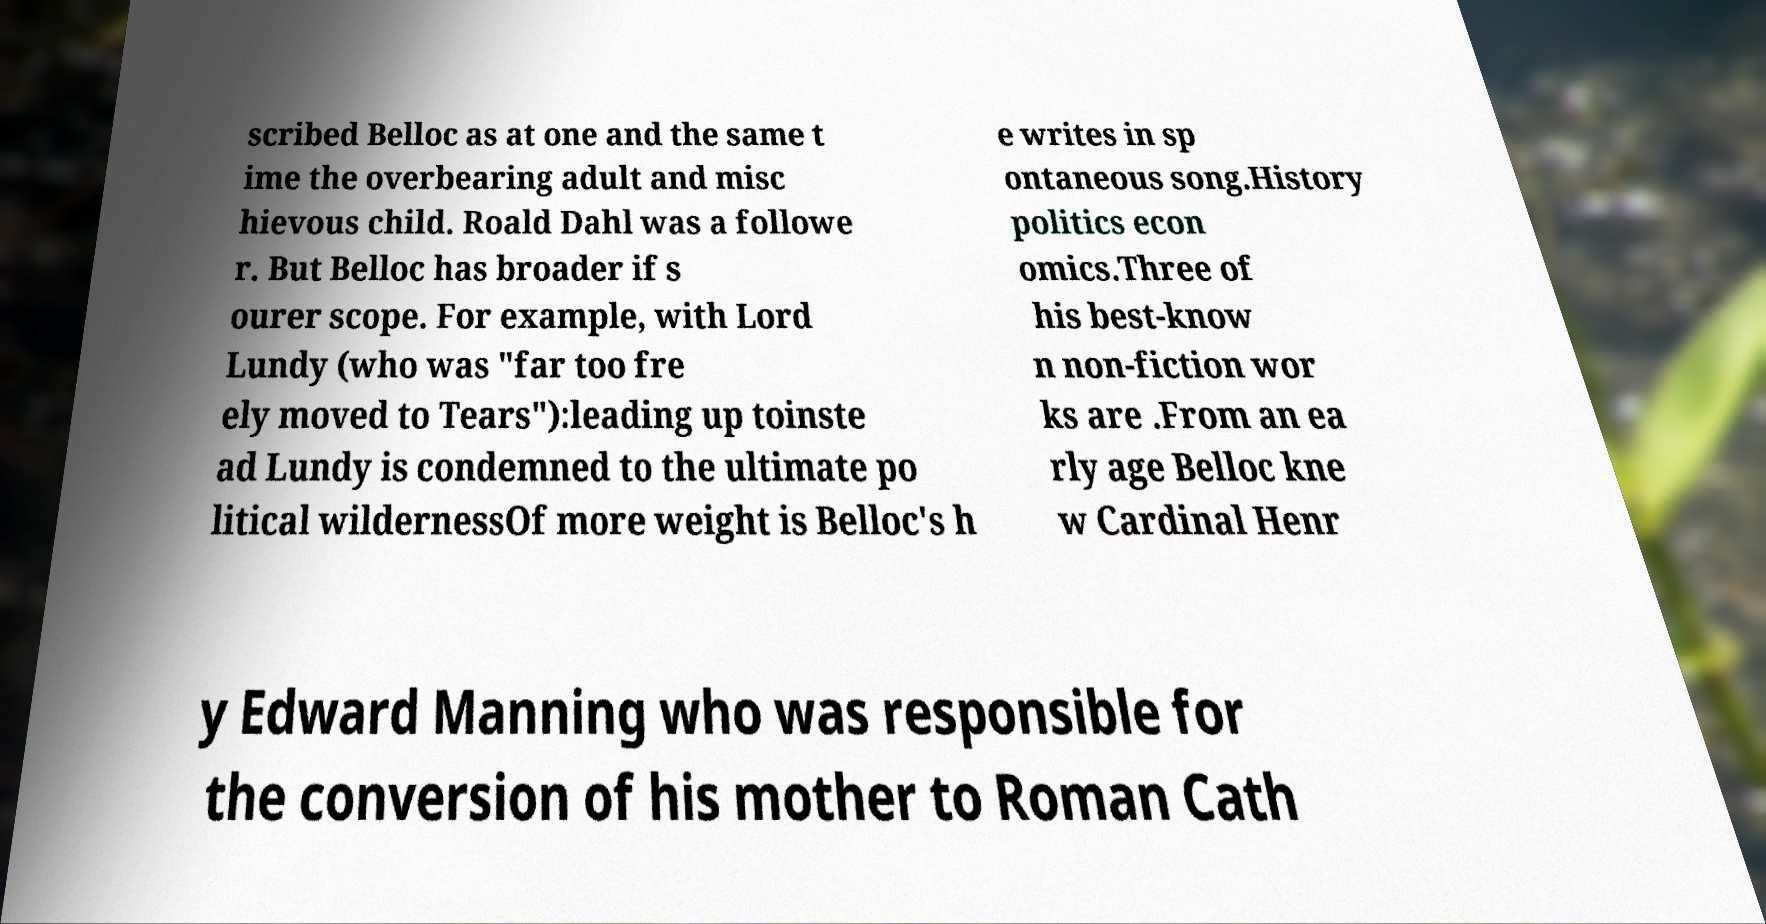I need the written content from this picture converted into text. Can you do that? scribed Belloc as at one and the same t ime the overbearing adult and misc hievous child. Roald Dahl was a followe r. But Belloc has broader if s ourer scope. For example, with Lord Lundy (who was "far too fre ely moved to Tears"):leading up toinste ad Lundy is condemned to the ultimate po litical wildernessOf more weight is Belloc's h e writes in sp ontaneous song.History politics econ omics.Three of his best-know n non-fiction wor ks are .From an ea rly age Belloc kne w Cardinal Henr y Edward Manning who was responsible for the conversion of his mother to Roman Cath 